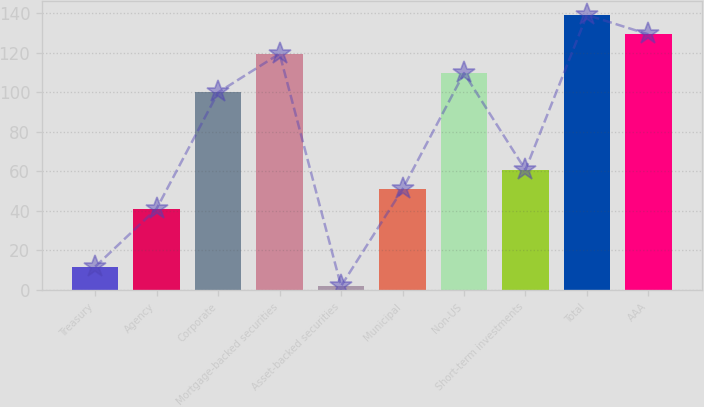Convert chart to OTSL. <chart><loc_0><loc_0><loc_500><loc_500><bar_chart><fcel>Treasury<fcel>Agency<fcel>Corporate<fcel>Mortgage-backed securities<fcel>Asset-backed securities<fcel>Municipal<fcel>Non-US<fcel>Short-term investments<fcel>Total<fcel>AAA<nl><fcel>11.8<fcel>41.2<fcel>100<fcel>119.6<fcel>2<fcel>51<fcel>109.8<fcel>60.8<fcel>139.2<fcel>129.4<nl></chart> 